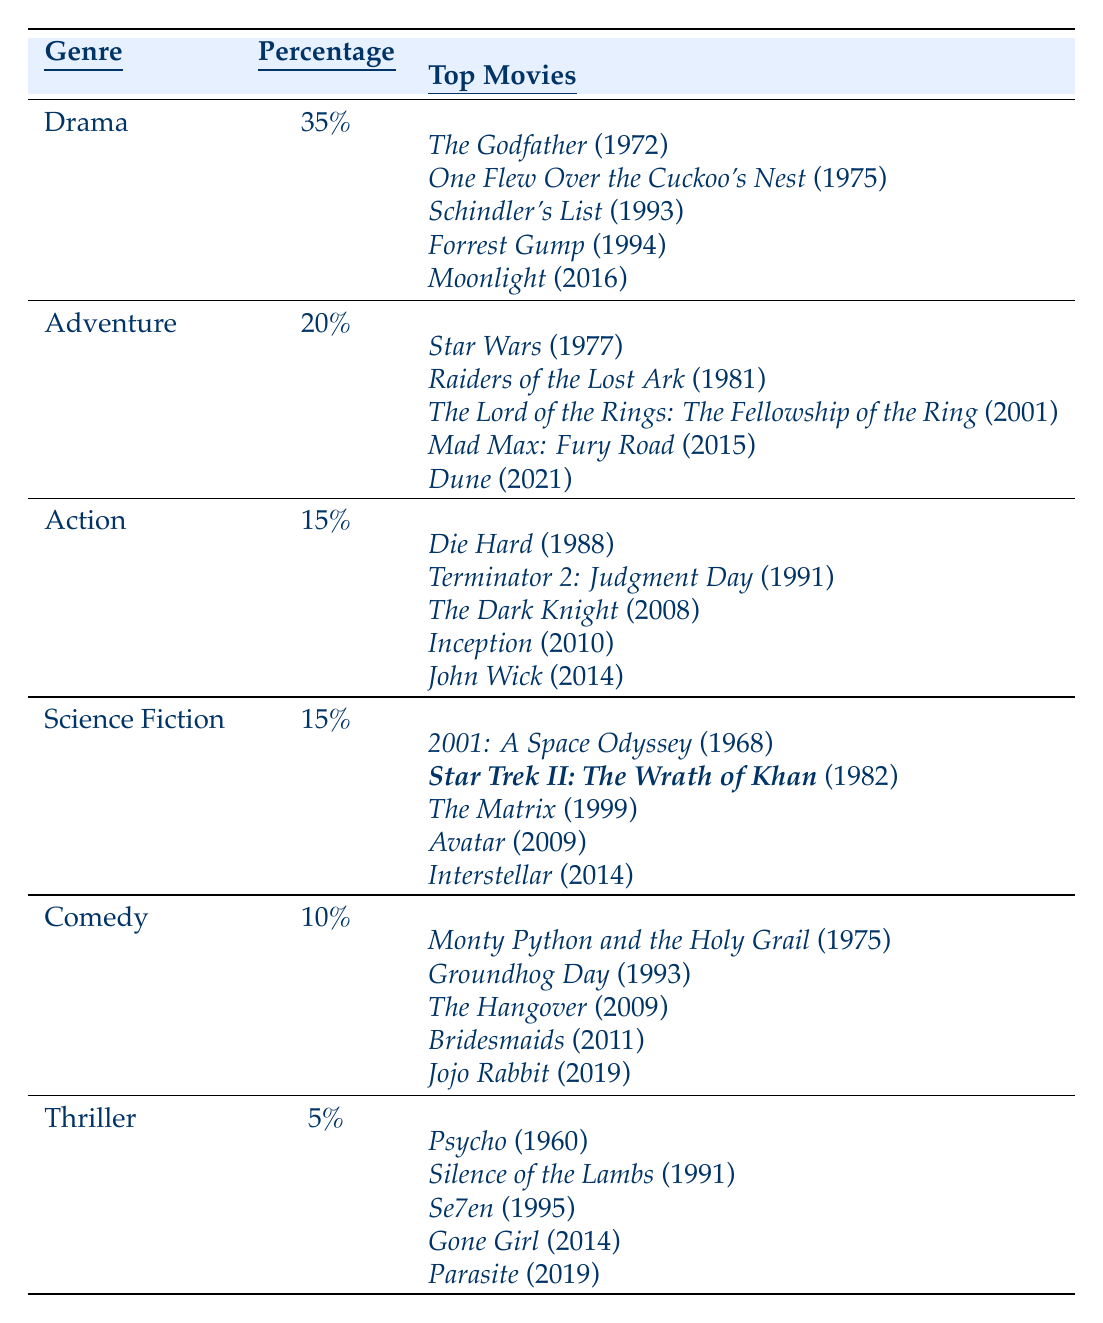What is the most common film genre in the table? The genre with the highest percentage in the table is Drama, which has 35%.
Answer: Drama How many top-rated movies are in the Adventure genre? There are 5 top movies listed under the Adventure genre.
Answer: 5 Which genre has the lowest percentage? The genre with the lowest percentage is Thriller, with 5%.
Answer: Thriller What percentage of top-rated movies are classified as Comedy? The percentage for Comedy is 10%.
Answer: 10% What is the total percentage of Drama and Adventure genres combined? Adding the percentages, Drama (35%) + Adventure (20%) = 55%.
Answer: 55% Is Science Fiction genre represented by more or fewer top movies than Comedy genre? Both Science Fiction and Comedy genres have 5 top movies each, so they are equal.
Answer: Equal Which two genres have the same percentage? Action and Science Fiction both have a percentage of 15%.
Answer: Action and Science Fiction What are the titles of the top movies in the Thriller genre? The top movies listed in the Thriller genre are Psycho, Silence of the Lambs, Se7en, Gone Girl, and Parasite.
Answer: Psycho, Silence of the Lambs, Se7en, Gone Girl, Parasite If you combine Drama and Comedy genres together, what percentage do they represent? Adding their percentages, Drama (35%) + Comedy (10%) = 45%.
Answer: 45% Does the Adventure genre have more movies listed than the Thriller genre? Yes, Adventure has 5 movies listed while Thriller also has 5, but both are equal.
Answer: Equal 